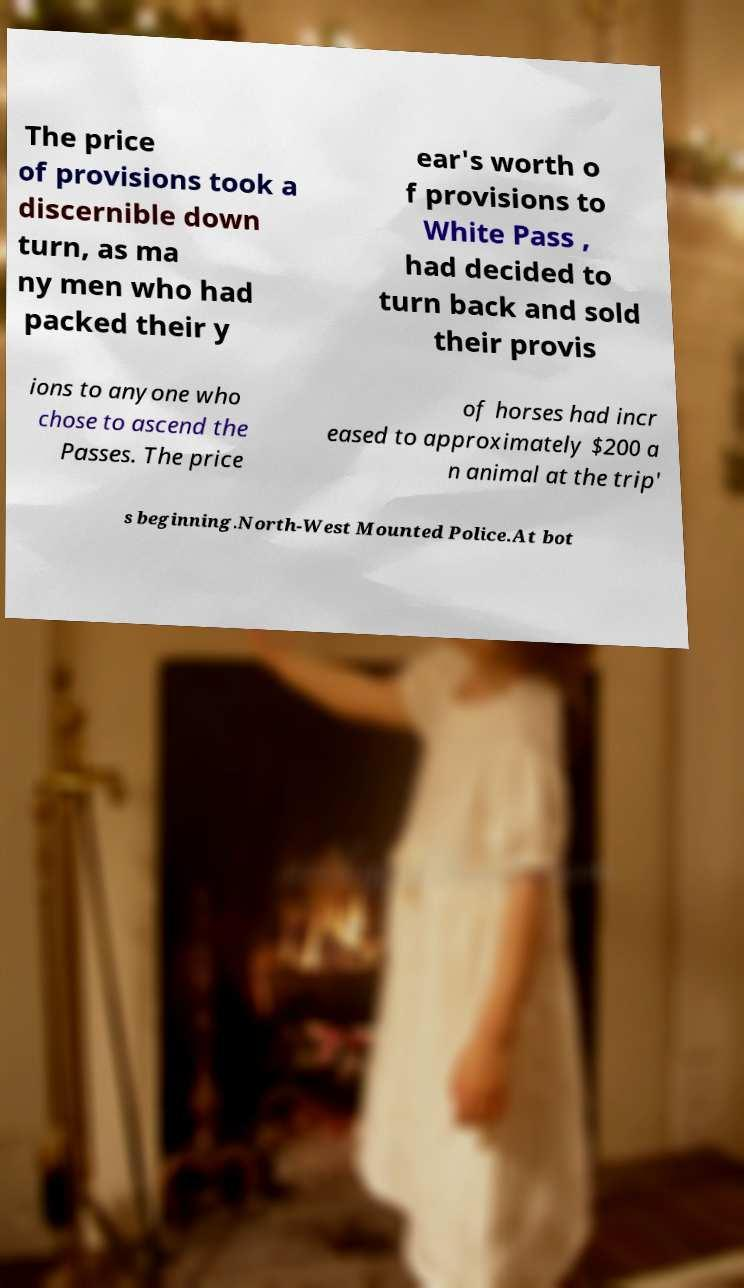What messages or text are displayed in this image? I need them in a readable, typed format. The price of provisions took a discernible down turn, as ma ny men who had packed their y ear's worth o f provisions to White Pass , had decided to turn back and sold their provis ions to anyone who chose to ascend the Passes. The price of horses had incr eased to approximately $200 a n animal at the trip' s beginning.North-West Mounted Police.At bot 